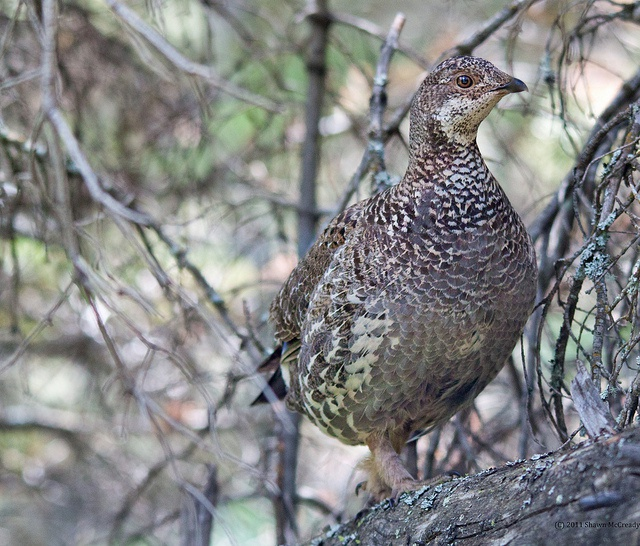Describe the objects in this image and their specific colors. I can see a bird in gray, darkgray, black, and lightgray tones in this image. 